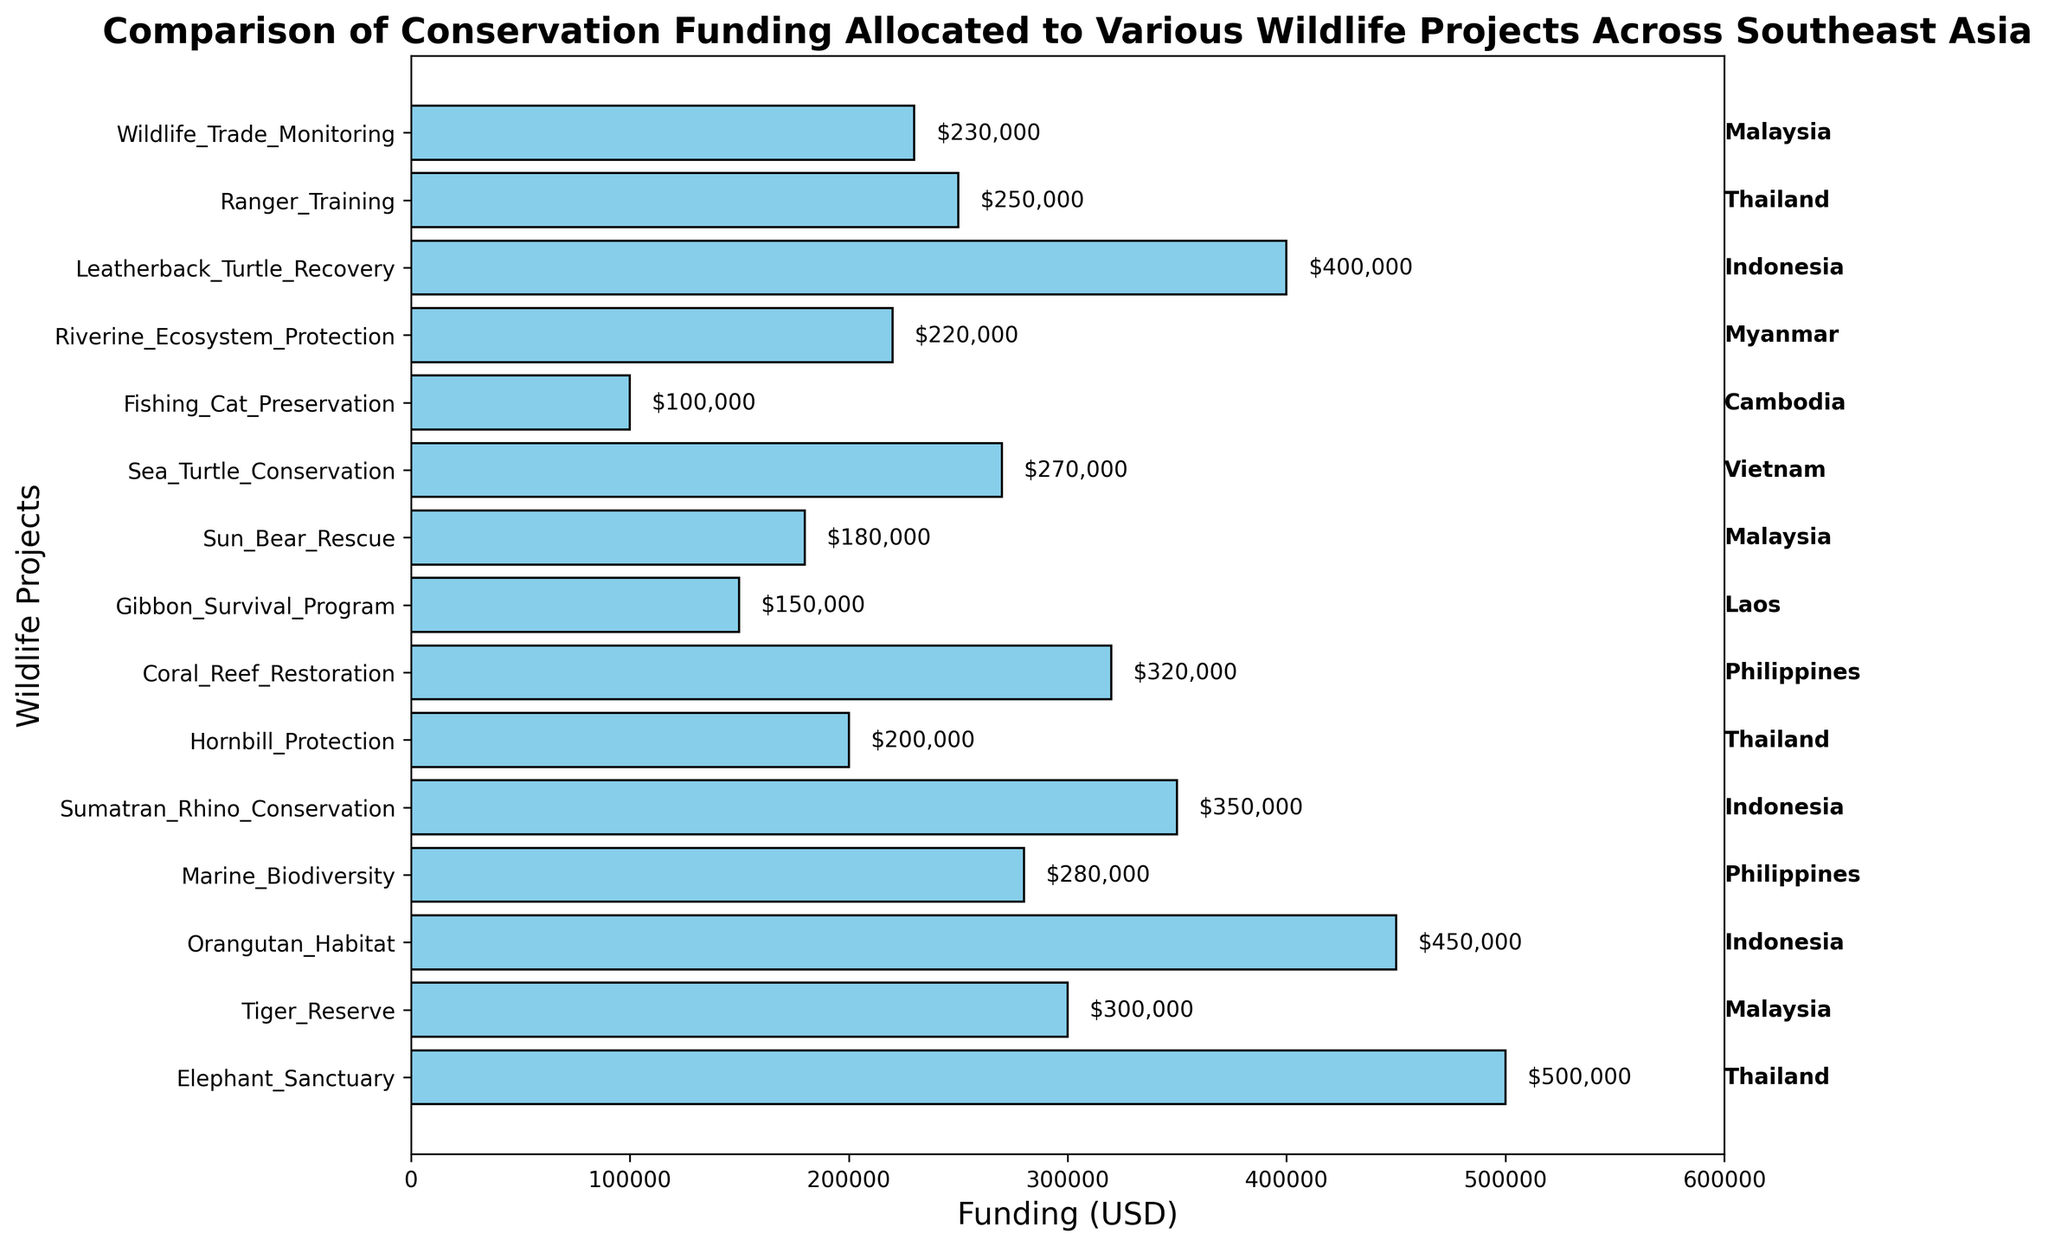Which wildlife project received the highest funding? Look at the length of the bars and their corresponding project names. The longest bar represents the project with the highest funding.
Answer: Elephant Sanctuary Which country has the most funded wildlife project? Determine which country the Elephant Sanctuary (the project with the highest funding) is located in based on the country labels.
Answer: Thailand How much more funding did the Elephant Sanctuary receive compared to the Gibbon Survival Program? Locate the bars for Elephant Sanctuary ($500,000) and Gibbon Survival Program ($150,000) and subtract the latter from the former: $500,000 - $150,000 = $350,000.
Answer: $350,000 What is the total funding allocated to projects in Thailand? Sum the funding amounts for the Elephant Sanctuary ($500,000), Hornbill Protection ($200,000), and Ranger Training ($250,000): $500,000 + $200,000 + $250,000 = $950,000.
Answer: $950,000 Which project received the least funding and how much was it? Identify the shortest bar on the chart and refer to its project name and funding amount.
Answer: Fishing Cat Preservation, $100,000 Compare the funding for marine conservation projects in the Philippines: Marine Biodiversity and Coral Reef Restoration. Which received more, and by how much? Check the bars for Marine Biodiversity ($280,000) and Coral Reef Restoration ($320,000). Subtract the smaller amount from the larger one: $320,000 - $280,000 = $40,000.
Answer: Coral Reef Restoration, $40,000 What is the average funding for all wildlife projects in Malaysia? Sum the funding for Tiger Reserve ($300,000), Sun Bear Rescue ($180,000), and Wildlife Trade Monitoring ($230,000), then divide by 3: ($300,000 + $180,000 + $230,000) / 3 = $236,666.67.
Answer: $236,666.67 How does the funding for the Orangutan Habitat compare to the Leatherback Turtle Recovery? Identify the funding amounts ($450,000 for Orangutan Habitat and $400,000 for Leatherback Turtle Recovery) and compare them. The Orangutan Habitat is greater: $450,000 > $400,000.
Answer: Orangutan Habitat Which country's projects have the closest funding amounts, and what are those projects? Look for countries with more than one project and compare the funding amounts: Sea Turtle Conservation $270,000 and Riverine Ecosystem Protection $220,000 in Myanmar. The difference is $270,000 - $220,000 = $50,000.
Answer: Myanmar, Sea Turtle Conservation and Riverine Ecosystem Protection, $50,000 Is there any project with funding exactly in the middle range between the highest and lowest funded projects? The highest funding is $500,000 and the lowest is $100,000. Middle range is (500,000 + 100,000) / 2 = $300,000. Check for a project with exactly $300,000: Tiger Reserve in Malaysia.
Answer: Tiger Reserve 